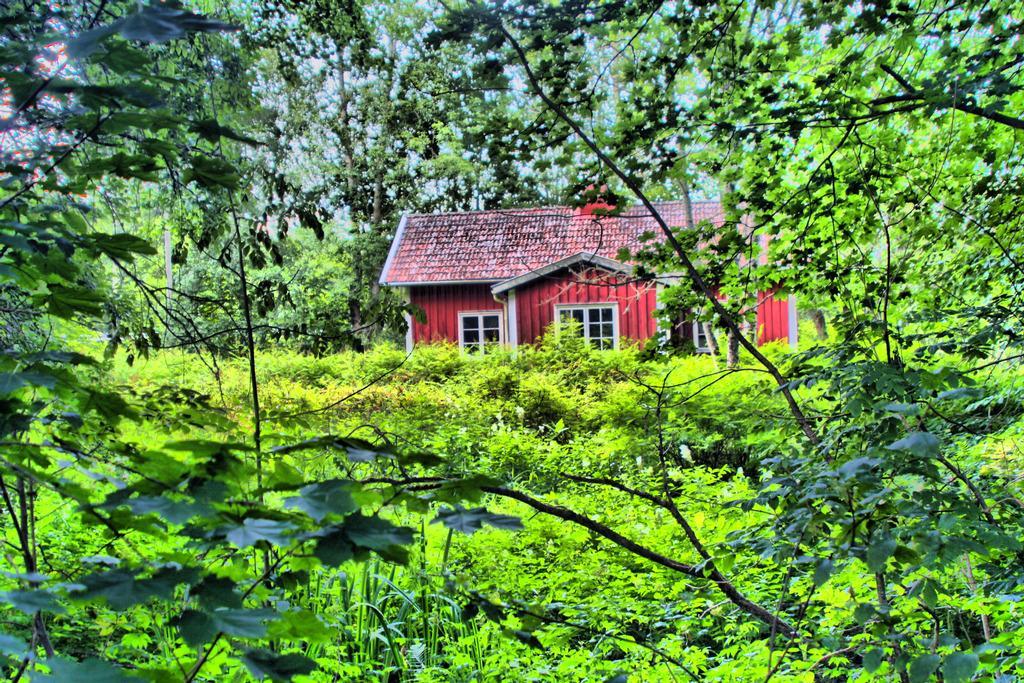Could you give a brief overview of what you see in this image? In this picture we can see few trees and a house in the middle of the image. 